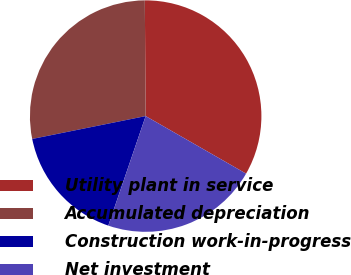Convert chart. <chart><loc_0><loc_0><loc_500><loc_500><pie_chart><fcel>Utility plant in service<fcel>Accumulated depreciation<fcel>Construction work-in-progress<fcel>Net investment<nl><fcel>33.4%<fcel>28.05%<fcel>16.6%<fcel>21.95%<nl></chart> 